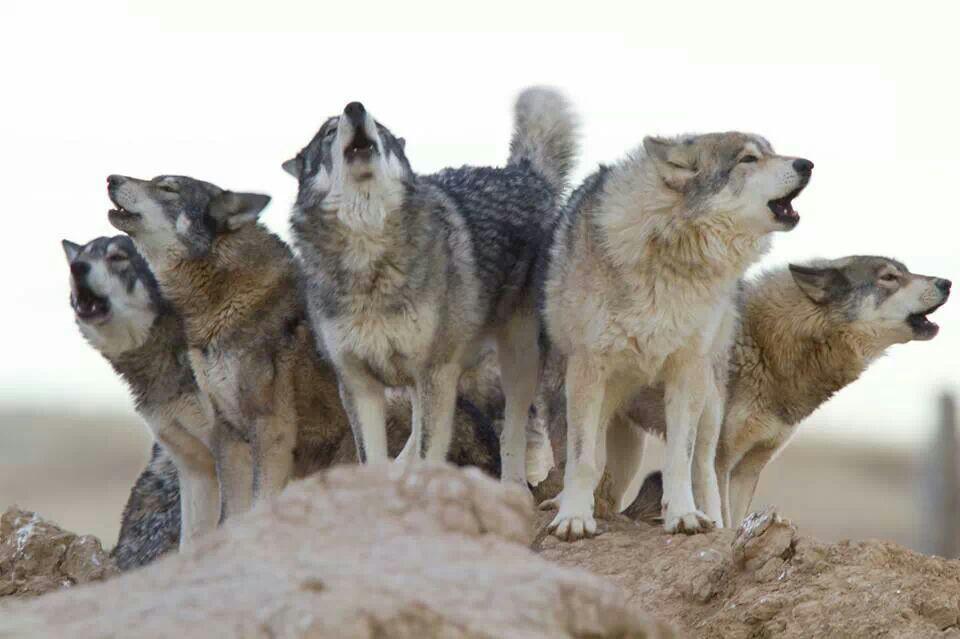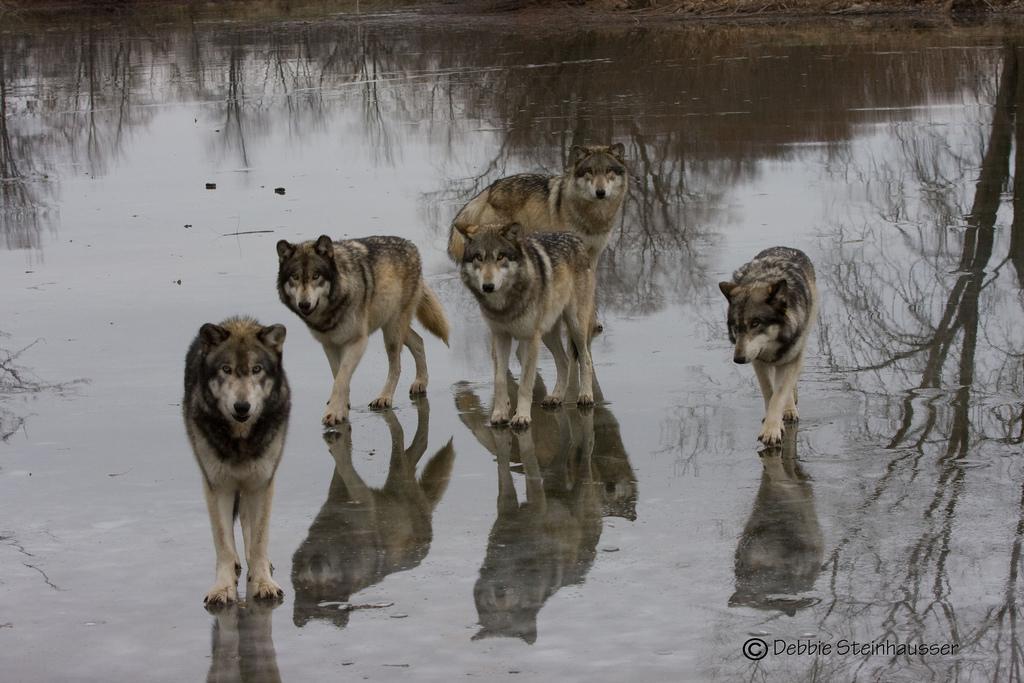The first image is the image on the left, the second image is the image on the right. Evaluate the accuracy of this statement regarding the images: "The image on the left contains at least five wolves that are howling.". Is it true? Answer yes or no. Yes. The first image is the image on the left, the second image is the image on the right. Examine the images to the left and right. Is the description "There are some wolves with white necks that have their heads titled up and are howling." accurate? Answer yes or no. Yes. 